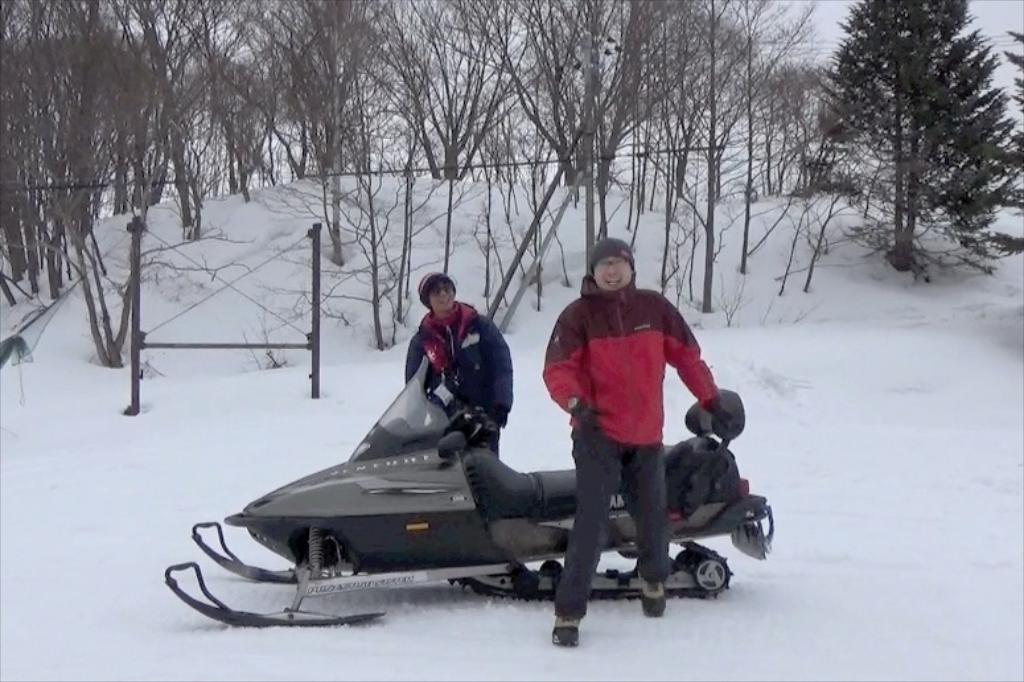How would you summarize this image in a sentence or two? In this picture I can see there are two men standing and there is a snowmobile. There is snow on the floor and in the backdrop there are few objects and trees. 